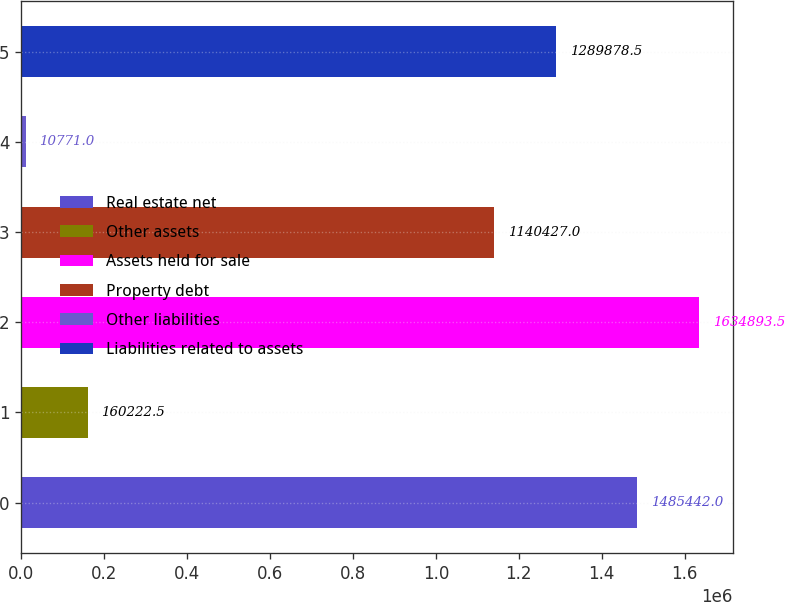<chart> <loc_0><loc_0><loc_500><loc_500><bar_chart><fcel>Real estate net<fcel>Other assets<fcel>Assets held for sale<fcel>Property debt<fcel>Other liabilities<fcel>Liabilities related to assets<nl><fcel>1.48544e+06<fcel>160222<fcel>1.63489e+06<fcel>1.14043e+06<fcel>10771<fcel>1.28988e+06<nl></chart> 